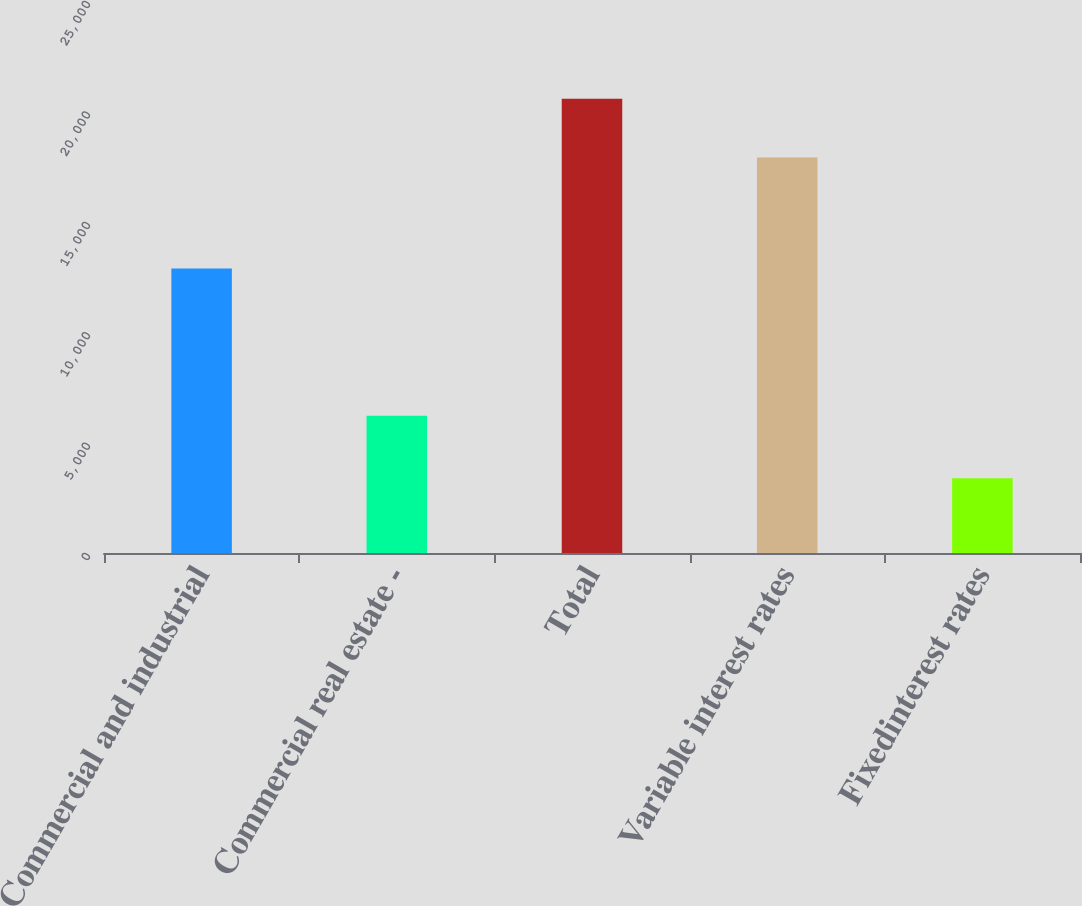Convert chart to OTSL. <chart><loc_0><loc_0><loc_500><loc_500><bar_chart><fcel>Commercial and industrial<fcel>Commercial real estate -<fcel>Total<fcel>Variable interest rates<fcel>Fixedinterest rates<nl><fcel>12888<fcel>6220<fcel>20577<fcel>17914<fcel>3379.8<nl></chart> 